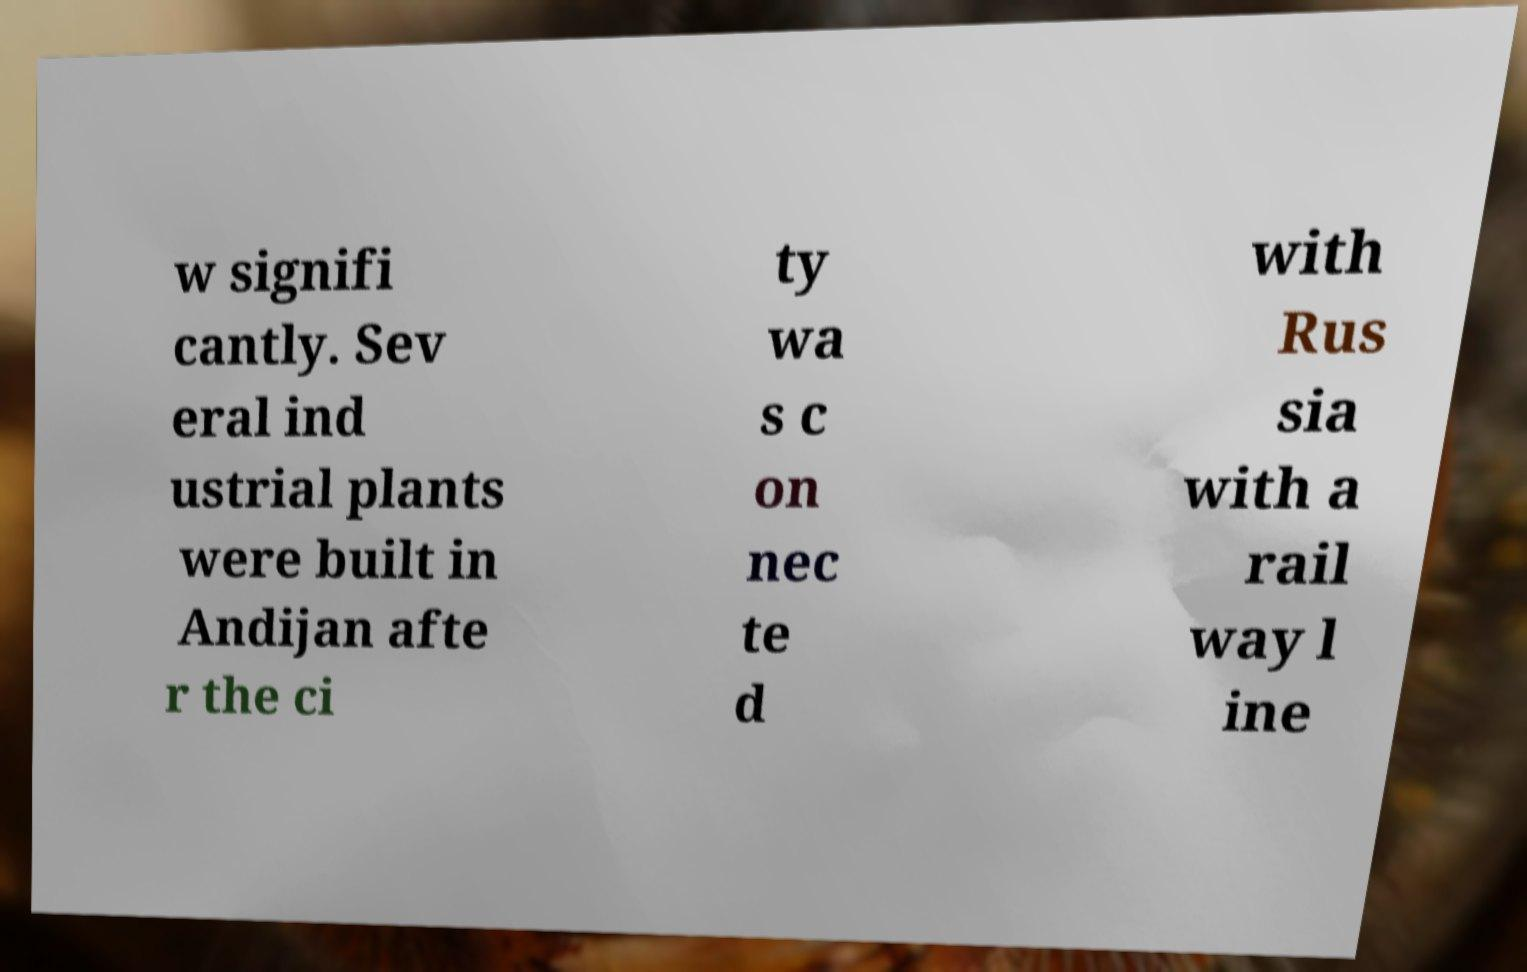I need the written content from this picture converted into text. Can you do that? w signifi cantly. Sev eral ind ustrial plants were built in Andijan afte r the ci ty wa s c on nec te d with Rus sia with a rail way l ine 